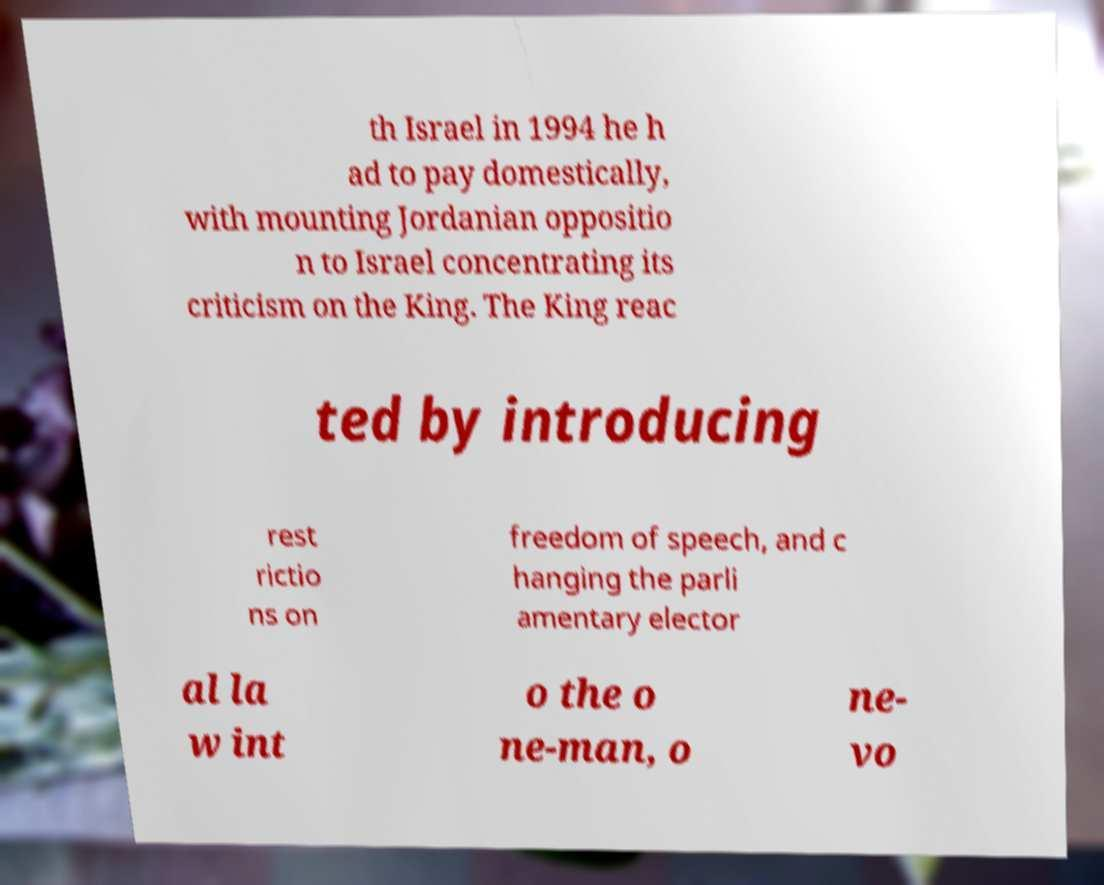What messages or text are displayed in this image? I need them in a readable, typed format. th Israel in 1994 he h ad to pay domestically, with mounting Jordanian oppositio n to Israel concentrating its criticism on the King. The King reac ted by introducing rest rictio ns on freedom of speech, and c hanging the parli amentary elector al la w int o the o ne-man, o ne- vo 